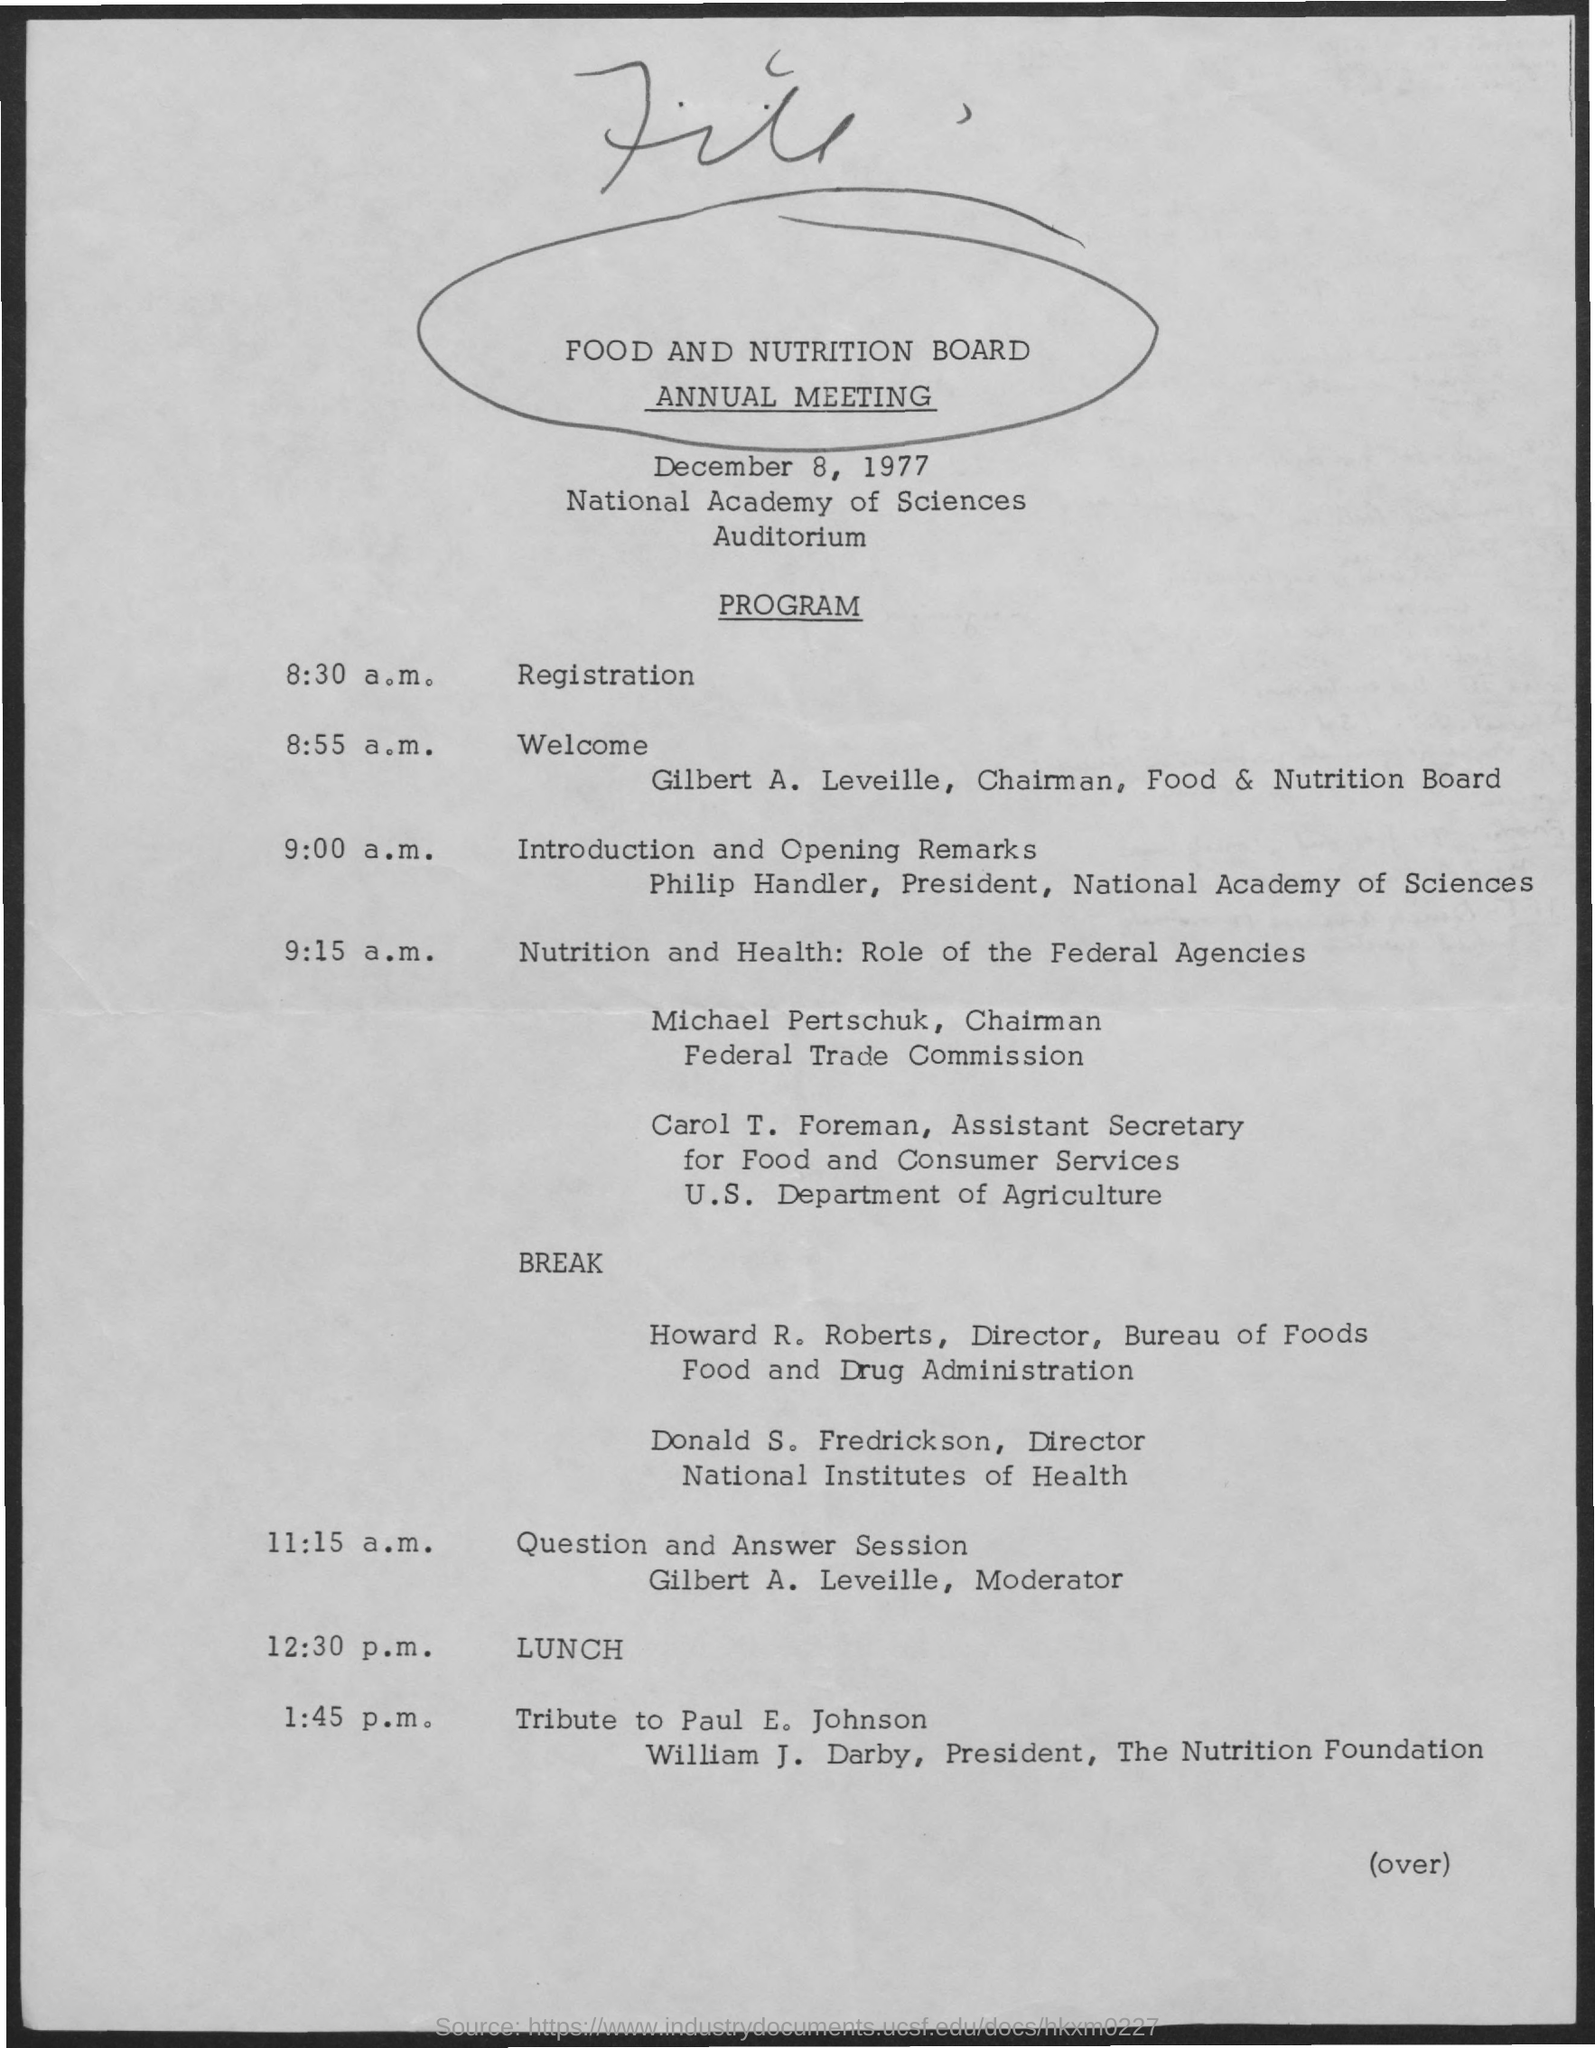Who is the president of Nutrition Foundation?
Your response must be concise. William J. Darby. Who is the chairman of Federal Trade Commission?
Your answer should be compact. Michael pertschuk. Who is moderating Question and Answer Session?
Offer a terse response. Gilbert a. leveille. 